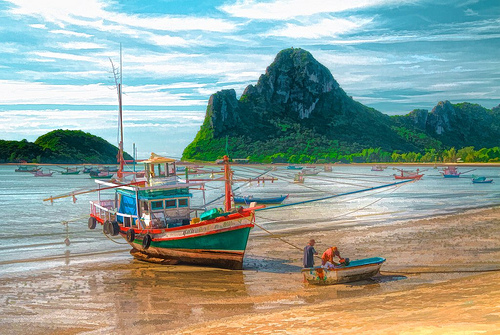<image>
Can you confirm if the boat is under the mountain? No. The boat is not positioned under the mountain. The vertical relationship between these objects is different. Is the boat on the hills? No. The boat is not positioned on the hills. They may be near each other, but the boat is not supported by or resting on top of the hills. 